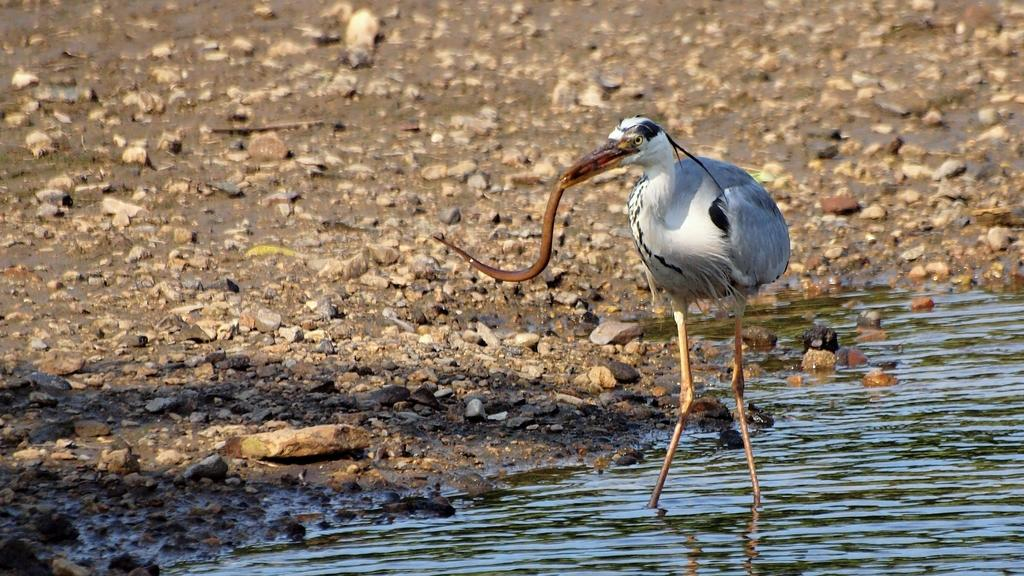What type of bird can be seen in the image? There is a white water bird in the image. Where is the bird located in the image? The bird is standing in water. What is the bird holding in its mouth? The bird has something in its mouth. What can be seen near the bird in the image? There are rocks beside the bird. What type of insect can be seen crawling on the bird's feathers in the image? There is no insect present on the bird's feathers in the image. How many matches are visible in the bird's beak in the image? There are no matches present in the bird's beak in the image. 